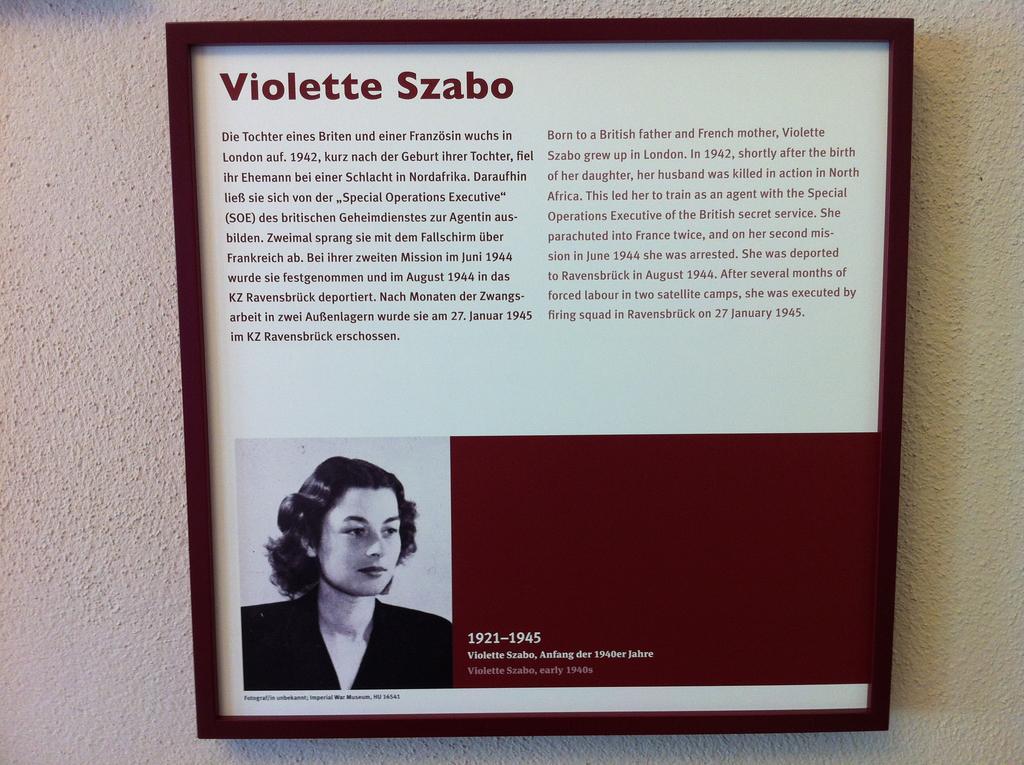Could you give a brief overview of what you see in this image? In this image there is a frame attached to the pole. In frame there is a picture of a person and there is some text. 